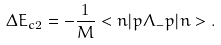Convert formula to latex. <formula><loc_0><loc_0><loc_500><loc_500>\Delta E _ { c 2 } = - \frac { 1 } { M } < n | { p } \Lambda _ { - } { p } | n > .</formula> 